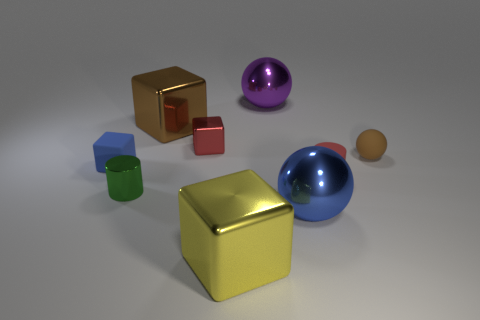Add 1 large brown matte cylinders. How many objects exist? 10 Subtract all balls. How many objects are left? 6 Add 6 rubber balls. How many rubber balls are left? 7 Add 3 cylinders. How many cylinders exist? 5 Subtract 1 blue spheres. How many objects are left? 8 Subtract all tiny green cylinders. Subtract all purple spheres. How many objects are left? 7 